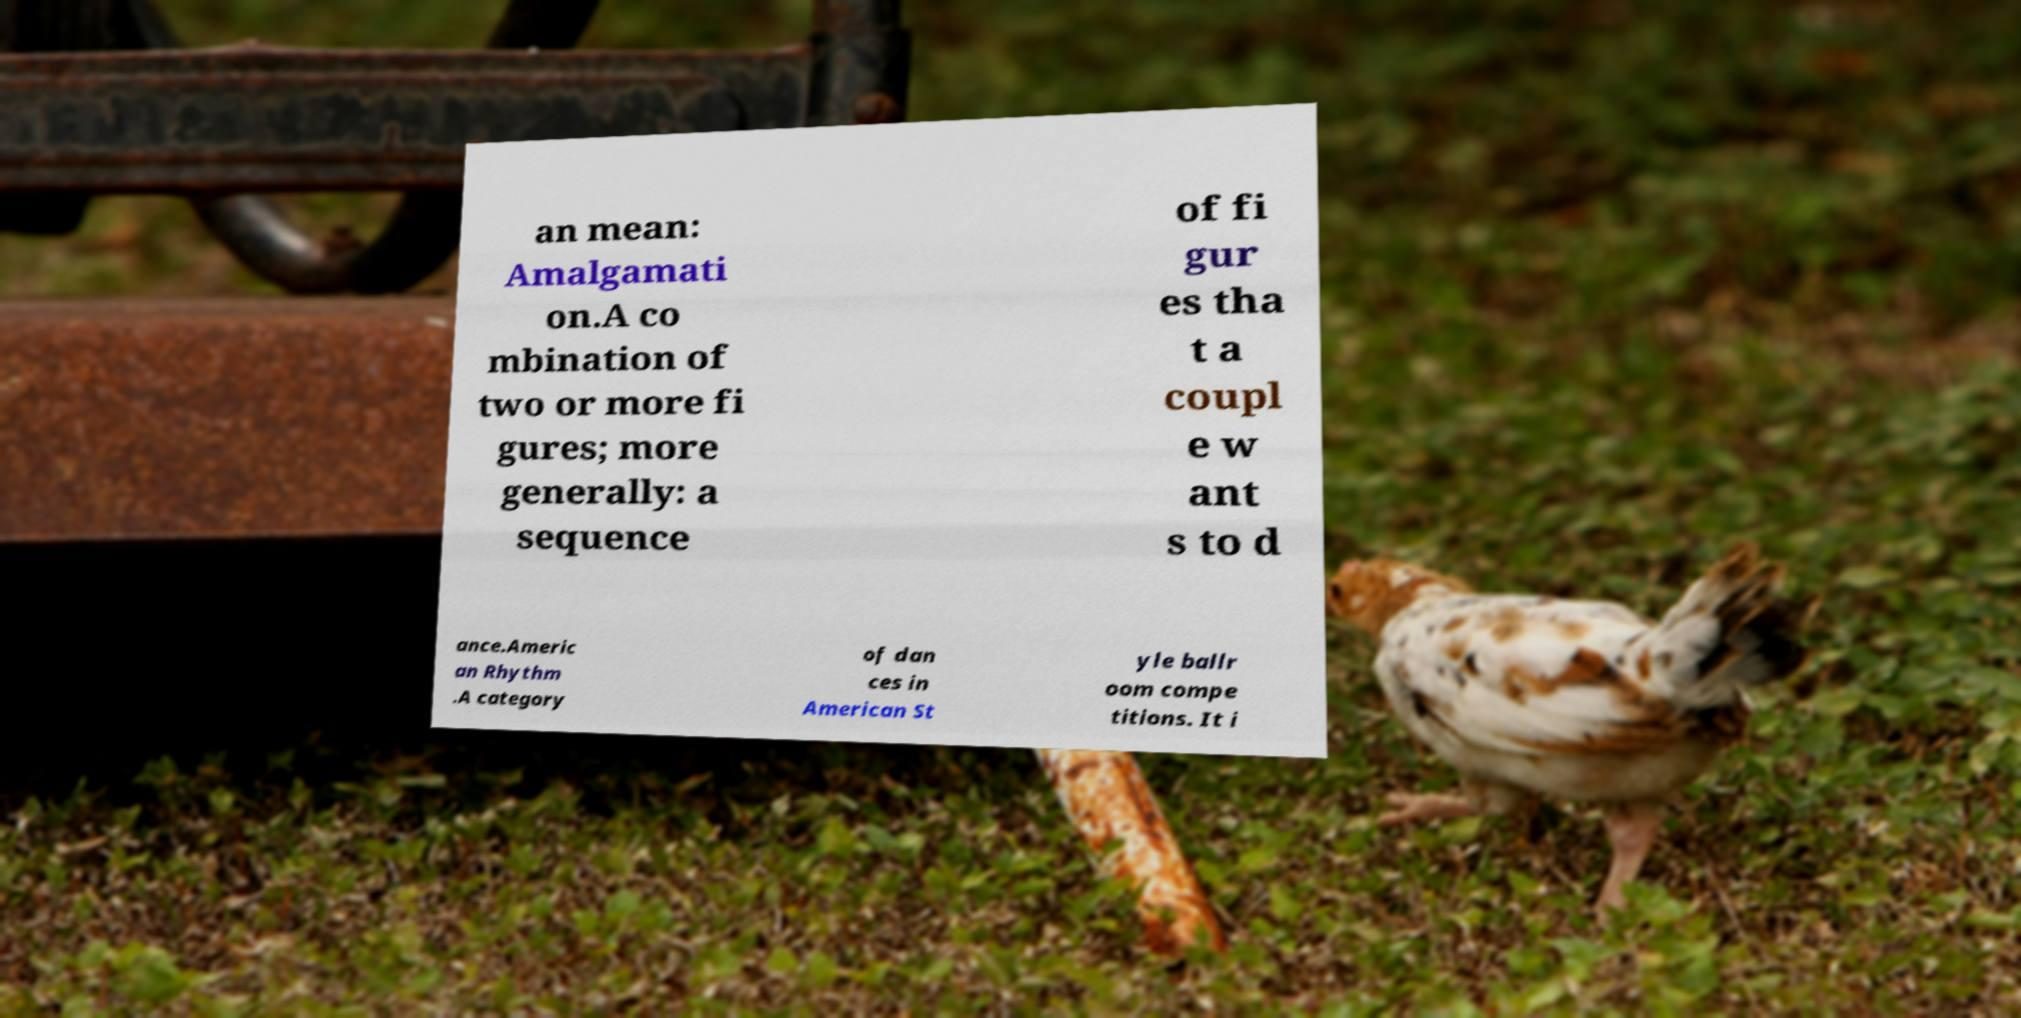Please read and relay the text visible in this image. What does it say? an mean: Amalgamati on.A co mbination of two or more fi gures; more generally: a sequence of fi gur es tha t a coupl e w ant s to d ance.Americ an Rhythm .A category of dan ces in American St yle ballr oom compe titions. It i 